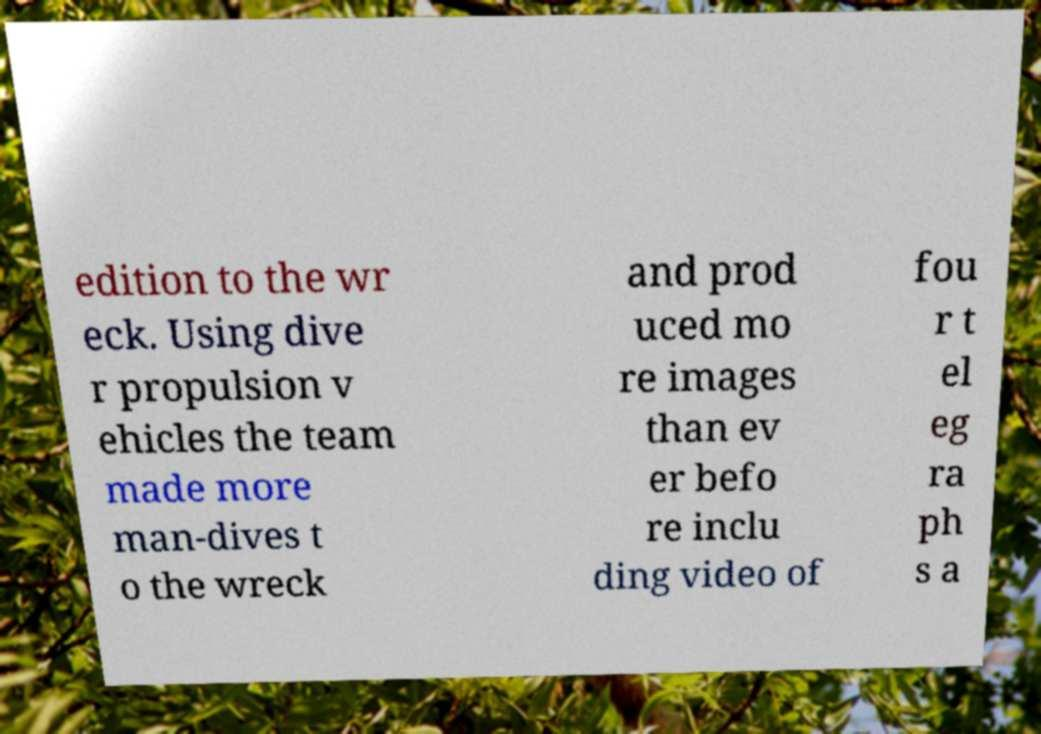Please read and relay the text visible in this image. What does it say? edition to the wr eck. Using dive r propulsion v ehicles the team made more man-dives t o the wreck and prod uced mo re images than ev er befo re inclu ding video of fou r t el eg ra ph s a 